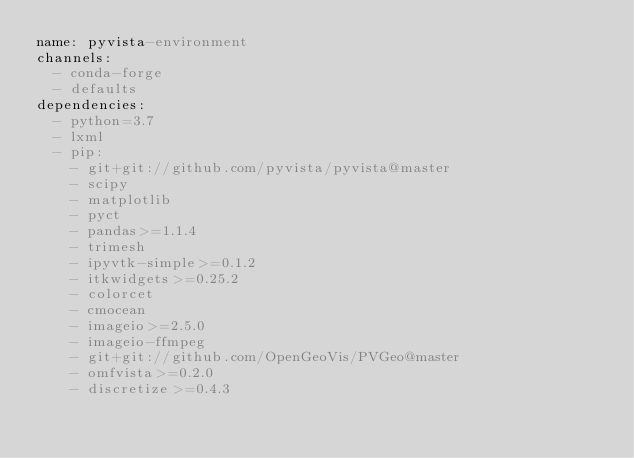Convert code to text. <code><loc_0><loc_0><loc_500><loc_500><_YAML_>name: pyvista-environment
channels:
  - conda-forge
  - defaults
dependencies:
  - python=3.7
  - lxml
  - pip:
    - git+git://github.com/pyvista/pyvista@master
    - scipy
    - matplotlib
    - pyct
    - pandas>=1.1.4
    - trimesh
    - ipyvtk-simple>=0.1.2
    - itkwidgets>=0.25.2
    - colorcet
    - cmocean
    - imageio>=2.5.0
    - imageio-ffmpeg
    - git+git://github.com/OpenGeoVis/PVGeo@master
    - omfvista>=0.2.0
    - discretize>=0.4.3
</code> 